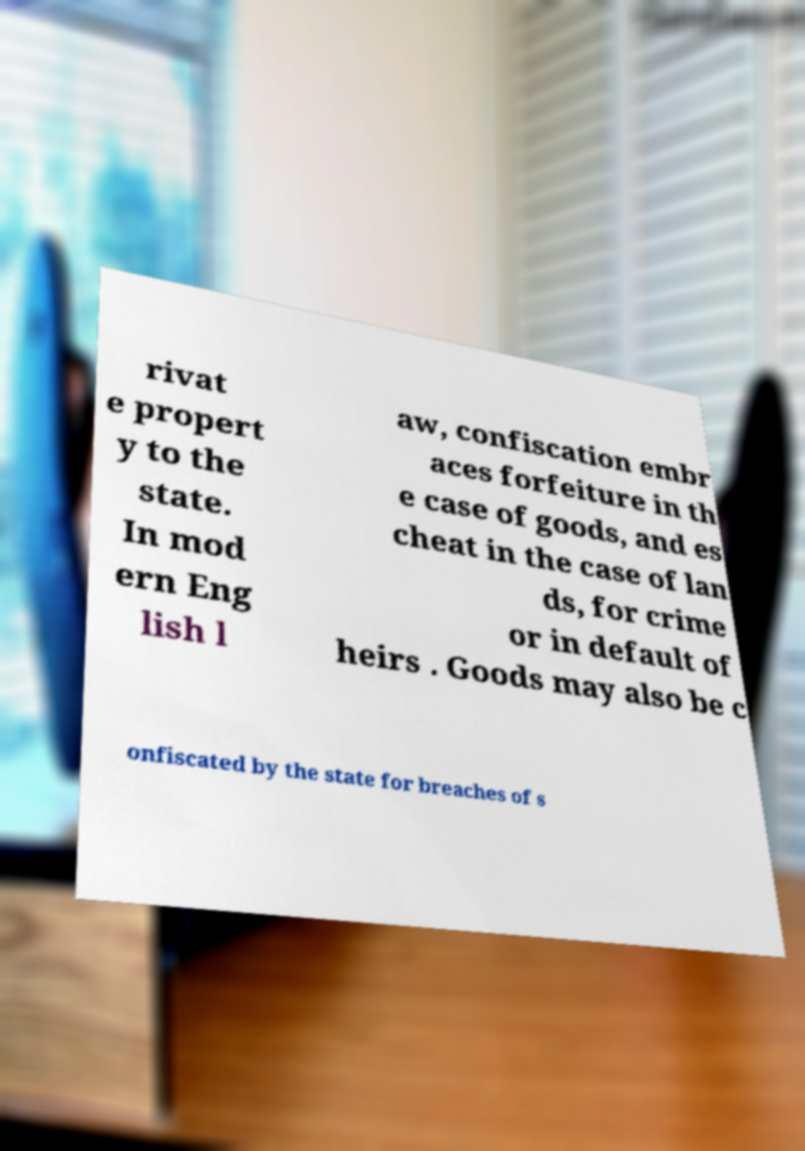Could you assist in decoding the text presented in this image and type it out clearly? rivat e propert y to the state. In mod ern Eng lish l aw, confiscation embr aces forfeiture in th e case of goods, and es cheat in the case of lan ds, for crime or in default of heirs . Goods may also be c onfiscated by the state for breaches of s 